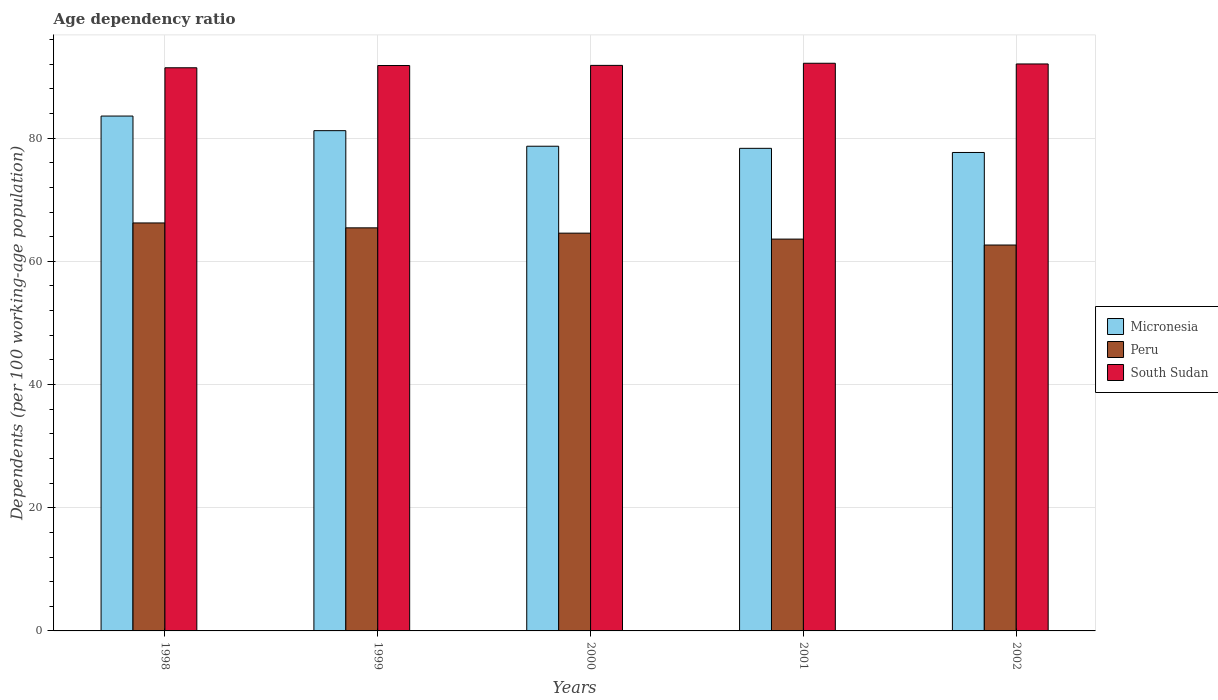Are the number of bars per tick equal to the number of legend labels?
Your answer should be very brief. Yes. How many bars are there on the 1st tick from the left?
Make the answer very short. 3. What is the label of the 3rd group of bars from the left?
Offer a very short reply. 2000. What is the age dependency ratio in in Peru in 2000?
Provide a short and direct response. 64.58. Across all years, what is the maximum age dependency ratio in in Micronesia?
Give a very brief answer. 83.59. Across all years, what is the minimum age dependency ratio in in Peru?
Make the answer very short. 62.65. In which year was the age dependency ratio in in South Sudan maximum?
Offer a terse response. 2001. What is the total age dependency ratio in in Peru in the graph?
Offer a terse response. 322.52. What is the difference between the age dependency ratio in in Peru in 1998 and that in 1999?
Offer a terse response. 0.79. What is the difference between the age dependency ratio in in Micronesia in 2000 and the age dependency ratio in in South Sudan in 1998?
Offer a very short reply. -12.74. What is the average age dependency ratio in in Micronesia per year?
Offer a terse response. 79.91. In the year 1998, what is the difference between the age dependency ratio in in Peru and age dependency ratio in in Micronesia?
Ensure brevity in your answer.  -17.36. In how many years, is the age dependency ratio in in Micronesia greater than 4 %?
Your answer should be compact. 5. What is the ratio of the age dependency ratio in in Peru in 1999 to that in 2002?
Ensure brevity in your answer.  1.04. Is the age dependency ratio in in Micronesia in 1998 less than that in 2002?
Keep it short and to the point. No. Is the difference between the age dependency ratio in in Peru in 2001 and 2002 greater than the difference between the age dependency ratio in in Micronesia in 2001 and 2002?
Your response must be concise. Yes. What is the difference between the highest and the second highest age dependency ratio in in South Sudan?
Offer a very short reply. 0.11. What is the difference between the highest and the lowest age dependency ratio in in Peru?
Your answer should be compact. 3.58. Is the sum of the age dependency ratio in in Micronesia in 1999 and 2001 greater than the maximum age dependency ratio in in Peru across all years?
Your answer should be very brief. Yes. What does the 2nd bar from the left in 2000 represents?
Your answer should be compact. Peru. What does the 2nd bar from the right in 1998 represents?
Ensure brevity in your answer.  Peru. Is it the case that in every year, the sum of the age dependency ratio in in Micronesia and age dependency ratio in in South Sudan is greater than the age dependency ratio in in Peru?
Keep it short and to the point. Yes. How many bars are there?
Your response must be concise. 15. Are all the bars in the graph horizontal?
Offer a terse response. No. How many years are there in the graph?
Provide a short and direct response. 5. What is the difference between two consecutive major ticks on the Y-axis?
Provide a succinct answer. 20. Are the values on the major ticks of Y-axis written in scientific E-notation?
Your answer should be very brief. No. Does the graph contain any zero values?
Provide a short and direct response. No. Where does the legend appear in the graph?
Offer a very short reply. Center right. How are the legend labels stacked?
Ensure brevity in your answer.  Vertical. What is the title of the graph?
Your response must be concise. Age dependency ratio. Does "High income: OECD" appear as one of the legend labels in the graph?
Provide a short and direct response. No. What is the label or title of the X-axis?
Ensure brevity in your answer.  Years. What is the label or title of the Y-axis?
Ensure brevity in your answer.  Dependents (per 100 working-age population). What is the Dependents (per 100 working-age population) in Micronesia in 1998?
Ensure brevity in your answer.  83.59. What is the Dependents (per 100 working-age population) of Peru in 1998?
Provide a short and direct response. 66.24. What is the Dependents (per 100 working-age population) in South Sudan in 1998?
Make the answer very short. 91.43. What is the Dependents (per 100 working-age population) of Micronesia in 1999?
Your answer should be compact. 81.22. What is the Dependents (per 100 working-age population) in Peru in 1999?
Ensure brevity in your answer.  65.44. What is the Dependents (per 100 working-age population) of South Sudan in 1999?
Keep it short and to the point. 91.79. What is the Dependents (per 100 working-age population) in Micronesia in 2000?
Provide a short and direct response. 78.69. What is the Dependents (per 100 working-age population) in Peru in 2000?
Ensure brevity in your answer.  64.58. What is the Dependents (per 100 working-age population) in South Sudan in 2000?
Offer a terse response. 91.82. What is the Dependents (per 100 working-age population) in Micronesia in 2001?
Keep it short and to the point. 78.35. What is the Dependents (per 100 working-age population) in Peru in 2001?
Provide a short and direct response. 63.61. What is the Dependents (per 100 working-age population) of South Sudan in 2001?
Your answer should be compact. 92.16. What is the Dependents (per 100 working-age population) of Micronesia in 2002?
Your answer should be very brief. 77.68. What is the Dependents (per 100 working-age population) in Peru in 2002?
Keep it short and to the point. 62.65. What is the Dependents (per 100 working-age population) in South Sudan in 2002?
Provide a short and direct response. 92.05. Across all years, what is the maximum Dependents (per 100 working-age population) of Micronesia?
Provide a short and direct response. 83.59. Across all years, what is the maximum Dependents (per 100 working-age population) of Peru?
Keep it short and to the point. 66.24. Across all years, what is the maximum Dependents (per 100 working-age population) in South Sudan?
Your answer should be compact. 92.16. Across all years, what is the minimum Dependents (per 100 working-age population) of Micronesia?
Your answer should be very brief. 77.68. Across all years, what is the minimum Dependents (per 100 working-age population) of Peru?
Offer a terse response. 62.65. Across all years, what is the minimum Dependents (per 100 working-age population) in South Sudan?
Offer a terse response. 91.43. What is the total Dependents (per 100 working-age population) in Micronesia in the graph?
Your response must be concise. 399.53. What is the total Dependents (per 100 working-age population) of Peru in the graph?
Ensure brevity in your answer.  322.52. What is the total Dependents (per 100 working-age population) in South Sudan in the graph?
Make the answer very short. 459.25. What is the difference between the Dependents (per 100 working-age population) of Micronesia in 1998 and that in 1999?
Make the answer very short. 2.37. What is the difference between the Dependents (per 100 working-age population) in Peru in 1998 and that in 1999?
Your answer should be very brief. 0.79. What is the difference between the Dependents (per 100 working-age population) of South Sudan in 1998 and that in 1999?
Your response must be concise. -0.36. What is the difference between the Dependents (per 100 working-age population) in Micronesia in 1998 and that in 2000?
Make the answer very short. 4.9. What is the difference between the Dependents (per 100 working-age population) in Peru in 1998 and that in 2000?
Offer a terse response. 1.66. What is the difference between the Dependents (per 100 working-age population) in South Sudan in 1998 and that in 2000?
Your response must be concise. -0.39. What is the difference between the Dependents (per 100 working-age population) of Micronesia in 1998 and that in 2001?
Ensure brevity in your answer.  5.24. What is the difference between the Dependents (per 100 working-age population) of Peru in 1998 and that in 2001?
Your answer should be very brief. 2.62. What is the difference between the Dependents (per 100 working-age population) in South Sudan in 1998 and that in 2001?
Offer a terse response. -0.73. What is the difference between the Dependents (per 100 working-age population) of Micronesia in 1998 and that in 2002?
Offer a very short reply. 5.91. What is the difference between the Dependents (per 100 working-age population) in Peru in 1998 and that in 2002?
Your answer should be very brief. 3.58. What is the difference between the Dependents (per 100 working-age population) of South Sudan in 1998 and that in 2002?
Keep it short and to the point. -0.62. What is the difference between the Dependents (per 100 working-age population) in Micronesia in 1999 and that in 2000?
Offer a very short reply. 2.52. What is the difference between the Dependents (per 100 working-age population) in Peru in 1999 and that in 2000?
Your response must be concise. 0.86. What is the difference between the Dependents (per 100 working-age population) of South Sudan in 1999 and that in 2000?
Your answer should be compact. -0.02. What is the difference between the Dependents (per 100 working-age population) of Micronesia in 1999 and that in 2001?
Your response must be concise. 2.87. What is the difference between the Dependents (per 100 working-age population) of Peru in 1999 and that in 2001?
Keep it short and to the point. 1.83. What is the difference between the Dependents (per 100 working-age population) of South Sudan in 1999 and that in 2001?
Your answer should be compact. -0.37. What is the difference between the Dependents (per 100 working-age population) in Micronesia in 1999 and that in 2002?
Offer a terse response. 3.54. What is the difference between the Dependents (per 100 working-age population) of Peru in 1999 and that in 2002?
Offer a very short reply. 2.79. What is the difference between the Dependents (per 100 working-age population) of South Sudan in 1999 and that in 2002?
Make the answer very short. -0.26. What is the difference between the Dependents (per 100 working-age population) of Micronesia in 2000 and that in 2001?
Make the answer very short. 0.34. What is the difference between the Dependents (per 100 working-age population) in Peru in 2000 and that in 2001?
Your response must be concise. 0.97. What is the difference between the Dependents (per 100 working-age population) of South Sudan in 2000 and that in 2001?
Ensure brevity in your answer.  -0.35. What is the difference between the Dependents (per 100 working-age population) of Micronesia in 2000 and that in 2002?
Give a very brief answer. 1.02. What is the difference between the Dependents (per 100 working-age population) of Peru in 2000 and that in 2002?
Your answer should be very brief. 1.93. What is the difference between the Dependents (per 100 working-age population) of South Sudan in 2000 and that in 2002?
Make the answer very short. -0.23. What is the difference between the Dependents (per 100 working-age population) of Micronesia in 2001 and that in 2002?
Offer a terse response. 0.67. What is the difference between the Dependents (per 100 working-age population) of Peru in 2001 and that in 2002?
Make the answer very short. 0.96. What is the difference between the Dependents (per 100 working-age population) of South Sudan in 2001 and that in 2002?
Your answer should be compact. 0.11. What is the difference between the Dependents (per 100 working-age population) of Micronesia in 1998 and the Dependents (per 100 working-age population) of Peru in 1999?
Give a very brief answer. 18.15. What is the difference between the Dependents (per 100 working-age population) of Micronesia in 1998 and the Dependents (per 100 working-age population) of South Sudan in 1999?
Your response must be concise. -8.2. What is the difference between the Dependents (per 100 working-age population) of Peru in 1998 and the Dependents (per 100 working-age population) of South Sudan in 1999?
Ensure brevity in your answer.  -25.56. What is the difference between the Dependents (per 100 working-age population) in Micronesia in 1998 and the Dependents (per 100 working-age population) in Peru in 2000?
Offer a terse response. 19.01. What is the difference between the Dependents (per 100 working-age population) of Micronesia in 1998 and the Dependents (per 100 working-age population) of South Sudan in 2000?
Your response must be concise. -8.23. What is the difference between the Dependents (per 100 working-age population) in Peru in 1998 and the Dependents (per 100 working-age population) in South Sudan in 2000?
Keep it short and to the point. -25.58. What is the difference between the Dependents (per 100 working-age population) of Micronesia in 1998 and the Dependents (per 100 working-age population) of Peru in 2001?
Provide a short and direct response. 19.98. What is the difference between the Dependents (per 100 working-age population) in Micronesia in 1998 and the Dependents (per 100 working-age population) in South Sudan in 2001?
Ensure brevity in your answer.  -8.57. What is the difference between the Dependents (per 100 working-age population) of Peru in 1998 and the Dependents (per 100 working-age population) of South Sudan in 2001?
Give a very brief answer. -25.93. What is the difference between the Dependents (per 100 working-age population) in Micronesia in 1998 and the Dependents (per 100 working-age population) in Peru in 2002?
Make the answer very short. 20.94. What is the difference between the Dependents (per 100 working-age population) in Micronesia in 1998 and the Dependents (per 100 working-age population) in South Sudan in 2002?
Ensure brevity in your answer.  -8.46. What is the difference between the Dependents (per 100 working-age population) in Peru in 1998 and the Dependents (per 100 working-age population) in South Sudan in 2002?
Make the answer very short. -25.81. What is the difference between the Dependents (per 100 working-age population) of Micronesia in 1999 and the Dependents (per 100 working-age population) of Peru in 2000?
Ensure brevity in your answer.  16.64. What is the difference between the Dependents (per 100 working-age population) of Micronesia in 1999 and the Dependents (per 100 working-age population) of South Sudan in 2000?
Give a very brief answer. -10.6. What is the difference between the Dependents (per 100 working-age population) of Peru in 1999 and the Dependents (per 100 working-age population) of South Sudan in 2000?
Provide a short and direct response. -26.38. What is the difference between the Dependents (per 100 working-age population) in Micronesia in 1999 and the Dependents (per 100 working-age population) in Peru in 2001?
Keep it short and to the point. 17.6. What is the difference between the Dependents (per 100 working-age population) of Micronesia in 1999 and the Dependents (per 100 working-age population) of South Sudan in 2001?
Ensure brevity in your answer.  -10.94. What is the difference between the Dependents (per 100 working-age population) of Peru in 1999 and the Dependents (per 100 working-age population) of South Sudan in 2001?
Your answer should be very brief. -26.72. What is the difference between the Dependents (per 100 working-age population) in Micronesia in 1999 and the Dependents (per 100 working-age population) in Peru in 2002?
Provide a short and direct response. 18.57. What is the difference between the Dependents (per 100 working-age population) in Micronesia in 1999 and the Dependents (per 100 working-age population) in South Sudan in 2002?
Keep it short and to the point. -10.83. What is the difference between the Dependents (per 100 working-age population) in Peru in 1999 and the Dependents (per 100 working-age population) in South Sudan in 2002?
Provide a short and direct response. -26.61. What is the difference between the Dependents (per 100 working-age population) of Micronesia in 2000 and the Dependents (per 100 working-age population) of Peru in 2001?
Give a very brief answer. 15.08. What is the difference between the Dependents (per 100 working-age population) in Micronesia in 2000 and the Dependents (per 100 working-age population) in South Sudan in 2001?
Offer a terse response. -13.47. What is the difference between the Dependents (per 100 working-age population) of Peru in 2000 and the Dependents (per 100 working-age population) of South Sudan in 2001?
Your response must be concise. -27.58. What is the difference between the Dependents (per 100 working-age population) in Micronesia in 2000 and the Dependents (per 100 working-age population) in Peru in 2002?
Ensure brevity in your answer.  16.04. What is the difference between the Dependents (per 100 working-age population) of Micronesia in 2000 and the Dependents (per 100 working-age population) of South Sudan in 2002?
Provide a succinct answer. -13.36. What is the difference between the Dependents (per 100 working-age population) of Peru in 2000 and the Dependents (per 100 working-age population) of South Sudan in 2002?
Provide a succinct answer. -27.47. What is the difference between the Dependents (per 100 working-age population) of Micronesia in 2001 and the Dependents (per 100 working-age population) of Peru in 2002?
Ensure brevity in your answer.  15.7. What is the difference between the Dependents (per 100 working-age population) of Micronesia in 2001 and the Dependents (per 100 working-age population) of South Sudan in 2002?
Give a very brief answer. -13.7. What is the difference between the Dependents (per 100 working-age population) in Peru in 2001 and the Dependents (per 100 working-age population) in South Sudan in 2002?
Your response must be concise. -28.44. What is the average Dependents (per 100 working-age population) of Micronesia per year?
Offer a terse response. 79.91. What is the average Dependents (per 100 working-age population) of Peru per year?
Ensure brevity in your answer.  64.5. What is the average Dependents (per 100 working-age population) of South Sudan per year?
Offer a very short reply. 91.85. In the year 1998, what is the difference between the Dependents (per 100 working-age population) in Micronesia and Dependents (per 100 working-age population) in Peru?
Provide a succinct answer. 17.36. In the year 1998, what is the difference between the Dependents (per 100 working-age population) of Micronesia and Dependents (per 100 working-age population) of South Sudan?
Your response must be concise. -7.84. In the year 1998, what is the difference between the Dependents (per 100 working-age population) of Peru and Dependents (per 100 working-age population) of South Sudan?
Give a very brief answer. -25.19. In the year 1999, what is the difference between the Dependents (per 100 working-age population) in Micronesia and Dependents (per 100 working-age population) in Peru?
Offer a very short reply. 15.78. In the year 1999, what is the difference between the Dependents (per 100 working-age population) of Micronesia and Dependents (per 100 working-age population) of South Sudan?
Your answer should be very brief. -10.58. In the year 1999, what is the difference between the Dependents (per 100 working-age population) of Peru and Dependents (per 100 working-age population) of South Sudan?
Make the answer very short. -26.35. In the year 2000, what is the difference between the Dependents (per 100 working-age population) of Micronesia and Dependents (per 100 working-age population) of Peru?
Provide a succinct answer. 14.11. In the year 2000, what is the difference between the Dependents (per 100 working-age population) of Micronesia and Dependents (per 100 working-age population) of South Sudan?
Keep it short and to the point. -13.12. In the year 2000, what is the difference between the Dependents (per 100 working-age population) of Peru and Dependents (per 100 working-age population) of South Sudan?
Your answer should be compact. -27.24. In the year 2001, what is the difference between the Dependents (per 100 working-age population) in Micronesia and Dependents (per 100 working-age population) in Peru?
Offer a terse response. 14.74. In the year 2001, what is the difference between the Dependents (per 100 working-age population) in Micronesia and Dependents (per 100 working-age population) in South Sudan?
Offer a very short reply. -13.81. In the year 2001, what is the difference between the Dependents (per 100 working-age population) of Peru and Dependents (per 100 working-age population) of South Sudan?
Your answer should be compact. -28.55. In the year 2002, what is the difference between the Dependents (per 100 working-age population) in Micronesia and Dependents (per 100 working-age population) in Peru?
Make the answer very short. 15.03. In the year 2002, what is the difference between the Dependents (per 100 working-age population) of Micronesia and Dependents (per 100 working-age population) of South Sudan?
Your answer should be compact. -14.37. In the year 2002, what is the difference between the Dependents (per 100 working-age population) in Peru and Dependents (per 100 working-age population) in South Sudan?
Keep it short and to the point. -29.4. What is the ratio of the Dependents (per 100 working-age population) in Micronesia in 1998 to that in 1999?
Give a very brief answer. 1.03. What is the ratio of the Dependents (per 100 working-age population) in Peru in 1998 to that in 1999?
Your response must be concise. 1.01. What is the ratio of the Dependents (per 100 working-age population) in Micronesia in 1998 to that in 2000?
Your answer should be compact. 1.06. What is the ratio of the Dependents (per 100 working-age population) of Peru in 1998 to that in 2000?
Provide a succinct answer. 1.03. What is the ratio of the Dependents (per 100 working-age population) of Micronesia in 1998 to that in 2001?
Offer a terse response. 1.07. What is the ratio of the Dependents (per 100 working-age population) of Peru in 1998 to that in 2001?
Provide a short and direct response. 1.04. What is the ratio of the Dependents (per 100 working-age population) of South Sudan in 1998 to that in 2001?
Offer a very short reply. 0.99. What is the ratio of the Dependents (per 100 working-age population) of Micronesia in 1998 to that in 2002?
Provide a succinct answer. 1.08. What is the ratio of the Dependents (per 100 working-age population) in Peru in 1998 to that in 2002?
Provide a short and direct response. 1.06. What is the ratio of the Dependents (per 100 working-age population) in South Sudan in 1998 to that in 2002?
Your response must be concise. 0.99. What is the ratio of the Dependents (per 100 working-age population) in Micronesia in 1999 to that in 2000?
Give a very brief answer. 1.03. What is the ratio of the Dependents (per 100 working-age population) in Peru in 1999 to that in 2000?
Give a very brief answer. 1.01. What is the ratio of the Dependents (per 100 working-age population) in South Sudan in 1999 to that in 2000?
Keep it short and to the point. 1. What is the ratio of the Dependents (per 100 working-age population) in Micronesia in 1999 to that in 2001?
Offer a very short reply. 1.04. What is the ratio of the Dependents (per 100 working-age population) of Peru in 1999 to that in 2001?
Give a very brief answer. 1.03. What is the ratio of the Dependents (per 100 working-age population) in South Sudan in 1999 to that in 2001?
Keep it short and to the point. 1. What is the ratio of the Dependents (per 100 working-age population) of Micronesia in 1999 to that in 2002?
Keep it short and to the point. 1.05. What is the ratio of the Dependents (per 100 working-age population) of Peru in 1999 to that in 2002?
Offer a very short reply. 1.04. What is the ratio of the Dependents (per 100 working-age population) of Peru in 2000 to that in 2001?
Provide a short and direct response. 1.02. What is the ratio of the Dependents (per 100 working-age population) in Micronesia in 2000 to that in 2002?
Provide a short and direct response. 1.01. What is the ratio of the Dependents (per 100 working-age population) of Peru in 2000 to that in 2002?
Your answer should be compact. 1.03. What is the ratio of the Dependents (per 100 working-age population) in South Sudan in 2000 to that in 2002?
Make the answer very short. 1. What is the ratio of the Dependents (per 100 working-age population) of Micronesia in 2001 to that in 2002?
Give a very brief answer. 1.01. What is the ratio of the Dependents (per 100 working-age population) of Peru in 2001 to that in 2002?
Make the answer very short. 1.02. What is the difference between the highest and the second highest Dependents (per 100 working-age population) in Micronesia?
Offer a very short reply. 2.37. What is the difference between the highest and the second highest Dependents (per 100 working-age population) in Peru?
Your response must be concise. 0.79. What is the difference between the highest and the second highest Dependents (per 100 working-age population) of South Sudan?
Your answer should be very brief. 0.11. What is the difference between the highest and the lowest Dependents (per 100 working-age population) in Micronesia?
Make the answer very short. 5.91. What is the difference between the highest and the lowest Dependents (per 100 working-age population) of Peru?
Ensure brevity in your answer.  3.58. What is the difference between the highest and the lowest Dependents (per 100 working-age population) of South Sudan?
Offer a very short reply. 0.73. 